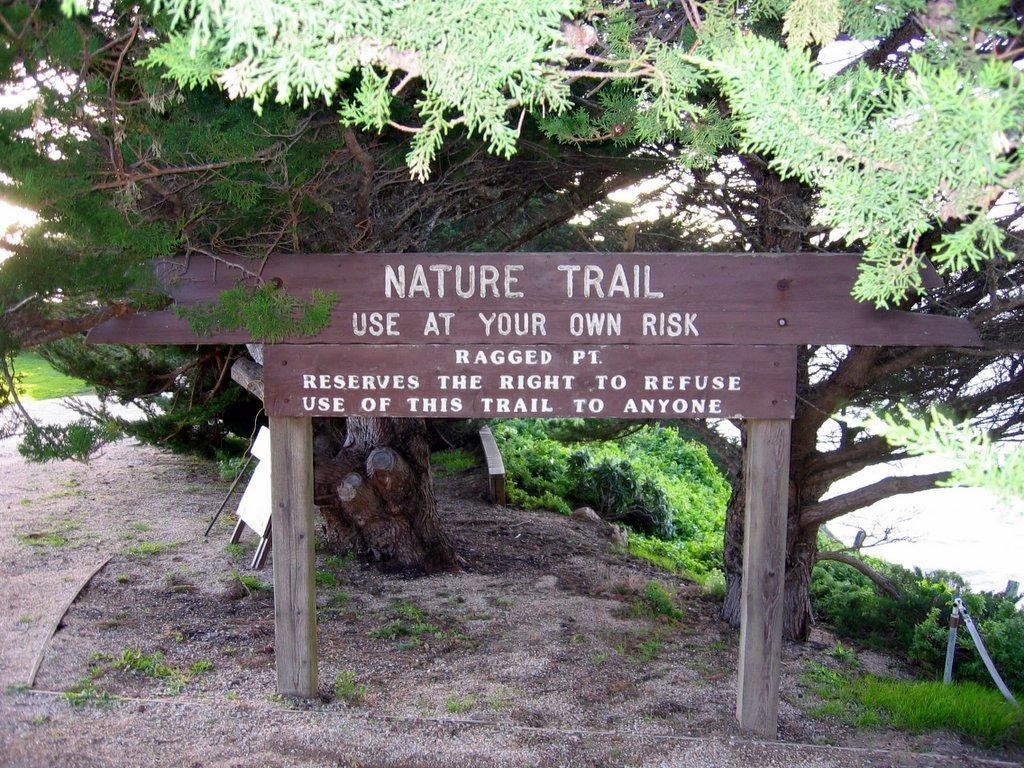What is the main object in the image? There is a wooden board with poles in the image. What can be seen on the wooden board? Something is written on the wooden board. What can be seen in the background of the image? There are trees and plants in the background of the image. How many arches are present in the image? There are no arches present in the image. 